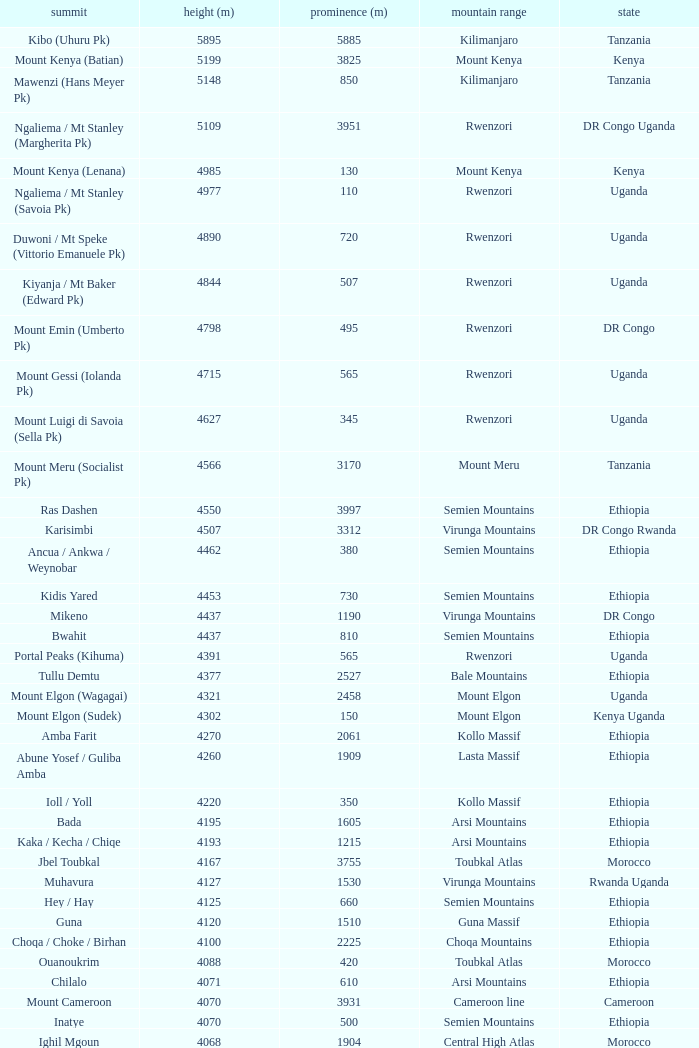Which Country has a Prominence (m) smaller than 1540, and a Height (m) smaller than 3530, and a Range of virunga mountains, and a Mountain of nyiragongo? DR Congo. Parse the full table. {'header': ['summit', 'height (m)', 'prominence (m)', 'mountain range', 'state'], 'rows': [['Kibo (Uhuru Pk)', '5895', '5885', 'Kilimanjaro', 'Tanzania'], ['Mount Kenya (Batian)', '5199', '3825', 'Mount Kenya', 'Kenya'], ['Mawenzi (Hans Meyer Pk)', '5148', '850', 'Kilimanjaro', 'Tanzania'], ['Ngaliema / Mt Stanley (Margherita Pk)', '5109', '3951', 'Rwenzori', 'DR Congo Uganda'], ['Mount Kenya (Lenana)', '4985', '130', 'Mount Kenya', 'Kenya'], ['Ngaliema / Mt Stanley (Savoia Pk)', '4977', '110', 'Rwenzori', 'Uganda'], ['Duwoni / Mt Speke (Vittorio Emanuele Pk)', '4890', '720', 'Rwenzori', 'Uganda'], ['Kiyanja / Mt Baker (Edward Pk)', '4844', '507', 'Rwenzori', 'Uganda'], ['Mount Emin (Umberto Pk)', '4798', '495', 'Rwenzori', 'DR Congo'], ['Mount Gessi (Iolanda Pk)', '4715', '565', 'Rwenzori', 'Uganda'], ['Mount Luigi di Savoia (Sella Pk)', '4627', '345', 'Rwenzori', 'Uganda'], ['Mount Meru (Socialist Pk)', '4566', '3170', 'Mount Meru', 'Tanzania'], ['Ras Dashen', '4550', '3997', 'Semien Mountains', 'Ethiopia'], ['Karisimbi', '4507', '3312', 'Virunga Mountains', 'DR Congo Rwanda'], ['Ancua / Ankwa / Weynobar', '4462', '380', 'Semien Mountains', 'Ethiopia'], ['Kidis Yared', '4453', '730', 'Semien Mountains', 'Ethiopia'], ['Mikeno', '4437', '1190', 'Virunga Mountains', 'DR Congo'], ['Bwahit', '4437', '810', 'Semien Mountains', 'Ethiopia'], ['Portal Peaks (Kihuma)', '4391', '565', 'Rwenzori', 'Uganda'], ['Tullu Demtu', '4377', '2527', 'Bale Mountains', 'Ethiopia'], ['Mount Elgon (Wagagai)', '4321', '2458', 'Mount Elgon', 'Uganda'], ['Mount Elgon (Sudek)', '4302', '150', 'Mount Elgon', 'Kenya Uganda'], ['Amba Farit', '4270', '2061', 'Kollo Massif', 'Ethiopia'], ['Abune Yosef / Guliba Amba', '4260', '1909', 'Lasta Massif', 'Ethiopia'], ['Ioll / Yoll', '4220', '350', 'Kollo Massif', 'Ethiopia'], ['Bada', '4195', '1605', 'Arsi Mountains', 'Ethiopia'], ['Kaka / Kecha / Chiqe', '4193', '1215', 'Arsi Mountains', 'Ethiopia'], ['Jbel Toubkal', '4167', '3755', 'Toubkal Atlas', 'Morocco'], ['Muhavura', '4127', '1530', 'Virunga Mountains', 'Rwanda Uganda'], ['Hey / Hay', '4125', '660', 'Semien Mountains', 'Ethiopia'], ['Guna', '4120', '1510', 'Guna Massif', 'Ethiopia'], ['Choqa / Choke / Birhan', '4100', '2225', 'Choqa Mountains', 'Ethiopia'], ['Ouanoukrim', '4088', '420', 'Toubkal Atlas', 'Morocco'], ['Chilalo', '4071', '610', 'Arsi Mountains', 'Ethiopia'], ['Mount Cameroon', '4070', '3931', 'Cameroon line', 'Cameroon'], ['Inatye', '4070', '500', 'Semien Mountains', 'Ethiopia'], ['Ighil Mgoun', '4068', '1904', 'Central High Atlas', 'Morocco'], ['Weshema / Wasema?', '4030', '420', 'Bale Mountains', 'Ethiopia'], ['Oldoinyo Lesatima', '4001', '2081', 'Aberdare Range', 'Kenya'], ["Jebel n'Tarourt / Tifnout / Iferouane", '3996', '910', 'Toubkal Atlas', 'Morocco'], ['Muggia', '3950', '500', 'Lasta Massif', 'Ethiopia'], ['Dubbai', '3941', '1540', 'Tigray Mountains', 'Ethiopia'], ['Taska n’Zat', '3912', '460', 'Toubkal Atlas', 'Morocco'], ['Aksouâl', '3903', '450', 'Toubkal Atlas', 'Morocco'], ['Mount Kinangop', '3902', '530', 'Aberdare Range', 'Kenya'], ['Cimbia', '3900', '590', 'Kollo Massif', 'Ethiopia'], ['Anrhemer / Ingehmar', '3892', '380', 'Toubkal Atlas', 'Morocco'], ['Ieciuol ?', '3840', '560', 'Kollo Massif', 'Ethiopia'], ['Kawa / Caua / Lajo', '3830', '475', 'Bale Mountains', 'Ethiopia'], ['Pt 3820', '3820', '450', 'Kollo Massif', 'Ethiopia'], ['Jbel Tignousti', '3819', '930', 'Central High Atlas', 'Morocco'], ['Filfo / Encuolo', '3805', '770', 'Arsi Mountains', 'Ethiopia'], ['Kosso Amba', '3805', '530', 'Lasta Massif', 'Ethiopia'], ['Jbel Ghat', '3781', '470', 'Central High Atlas', 'Morocco'], ['Baylamtu / Gavsigivla', '3777', '1120', 'Lasta Massif', 'Ethiopia'], ['Ouaougoulzat', '3763', '860', 'Central High Atlas', 'Morocco'], ['Somkaru', '3760', '530', 'Bale Mountains', 'Ethiopia'], ['Abieri', '3750', '780', 'Semien Mountains', 'Ethiopia'], ['Arin Ayachi', '3747', '1400', 'East High Atlas', 'Morocco'], ['Teide', '3718', '3718', 'Tenerife', 'Canary Islands'], ['Visoke / Bisoke', '3711', '585', 'Virunga Mountains', 'DR Congo Rwanda'], ['Sarenga', '3700', '1160', 'Tigray Mountains', 'Ethiopia'], ['Woti / Uoti', '3700', '1050', 'Eastern Escarpment', 'Ethiopia'], ['Pt 3700 (Kulsa?)', '3700', '490', 'Arsi Mountains', 'Ethiopia'], ['Loolmalassin', '3682', '2040', 'Crater Highlands', 'Tanzania'], ['Biala ?', '3680', '870', 'Lasta Massif', 'Ethiopia'], ['Azurki / Azourki', '3677', '790', 'Central High Atlas', 'Morocco'], ['Pt 3645', '3645', '910', 'Lasta Massif', 'Ethiopia'], ['Sabyinyo', '3634', '1010', 'Virunga Mountains', 'Rwanda DR Congo Uganda'], ['Mount Gurage / Guraghe', '3620', '1400', 'Gurage Mountains', 'Ethiopia'], ['Angour', '3616', '444', 'Toubkal Atlas', 'Morocco'], ['Jbel Igdat', '3615', '1609', 'West High Atlas', 'Morocco'], ["Jbel n'Anghomar", '3609', '1420', 'Central High Atlas', 'Morocco'], ['Yegura / Amba Moka', '3605', '420', 'Lasta Massif', 'Ethiopia'], ['Pt 3600 (Kitir?)', '3600', '870', 'Eastern Escarpment', 'Ethiopia'], ['Pt 3600', '3600', '610', 'Lasta Massif', 'Ethiopia'], ['Bar Meda high point', '3580', '520', 'Eastern Escarpment', 'Ethiopia'], ['Jbel Erdouz', '3579', '690', 'West High Atlas', 'Morocco'], ['Mount Gugu', '3570', '940', 'Mount Gugu', 'Ethiopia'], ['Gesh Megal (?)', '3570', '520', 'Gurage Mountains', 'Ethiopia'], ['Gughe', '3568', '2013', 'Balta Mountains', 'Ethiopia'], ['Megezez', '3565', '690', 'Eastern Escarpment', 'Ethiopia'], ['Pt 3555', '3555', '475', 'Lasta Massif', 'Ethiopia'], ['Jbel Tinergwet', '3551', '880', 'West High Atlas', 'Morocco'], ['Amba Alagi', '3550', '820', 'Tigray Mountains', 'Ethiopia'], ['Nakugen', '3530', '1510', 'Cherangany Hills', 'Kenya'], ['Gara Guda /Kara Gada', '3530', '900', 'Salale Mountains', 'Ethiopia'], ['Amonewas', '3530', '870', 'Choqa Mountains', 'Ethiopia'], ['Amedamit', '3530', '760', 'Choqa Mountains', 'Ethiopia'], ['Igoudamene', '3519', '550', 'Central High Atlas', 'Morocco'], ['Abuye Meda', '3505', '230', 'Eastern Escarpment', 'Ethiopia'], ['Thabana Ntlenyana', '3482', '2390', 'Drakensberg', 'Lesotho'], ['Mont Mohi', '3480', '1592', 'Mitumba Mountains', 'DR Congo'], ['Gahinga', '3474', '425', 'Virunga Mountains', 'Uganda Rwanda'], ['Nyiragongo', '3470', '1440', 'Virunga Mountains', 'DR Congo']]} 